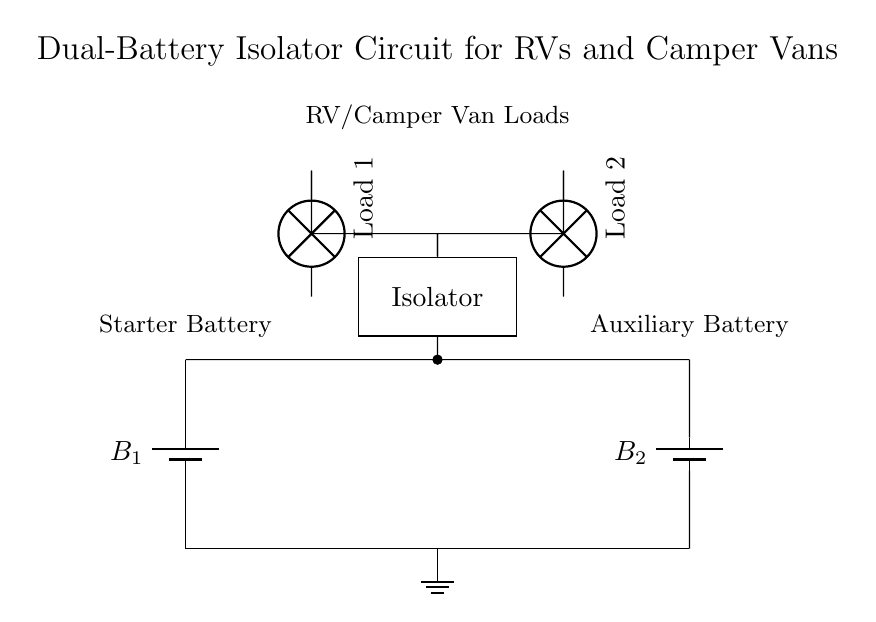What are the components visible in the circuit? The circuit shows two batteries, an isolator, and two loads depicted as lamps. The batteries are labeled as B1 and B2, while the loads are labeled as Load 1 and Load 2.
Answer: Two batteries, an isolator, two lamps How many batteries are present in the circuit? The diagram clearly shows two batteries at the bottom, labeled as B1 and B2.
Answer: Two What is the purpose of the isolator in this circuit? The isolator is used to manage the power distribution between the starter battery and the auxiliary battery, ensuring that loads can draw from both batteries while isolating them for safety and longevity.
Answer: Power management What type of connection is used between the batteries and the isolator? Both batteries are connected to the isolator via short connections represented by the straight lines in the circuit diagram, indicating a direct link without any additional components in between.
Answer: Short connections Why is there a ground connection in the circuit? The ground connection ensures that the circuit has a reference point for voltage and provides safety by allowing excess current to safely dissipate into the ground. This is critical in high power applications to prevent damage.
Answer: Safety and reference Which load is connected to the isolator via the north side? Load 1 is connected to the isolator via the north side. You can trace the connection from the isolator going upwards to the left to find Load 1's position.
Answer: Load 1 Which battery is considered the starter battery? The starter battery is labeled as B1 and is located on the left side of the circuit diagram, distinctly differentiating it from the auxiliary battery, which is labeled B2 on the right side.
Answer: B1 